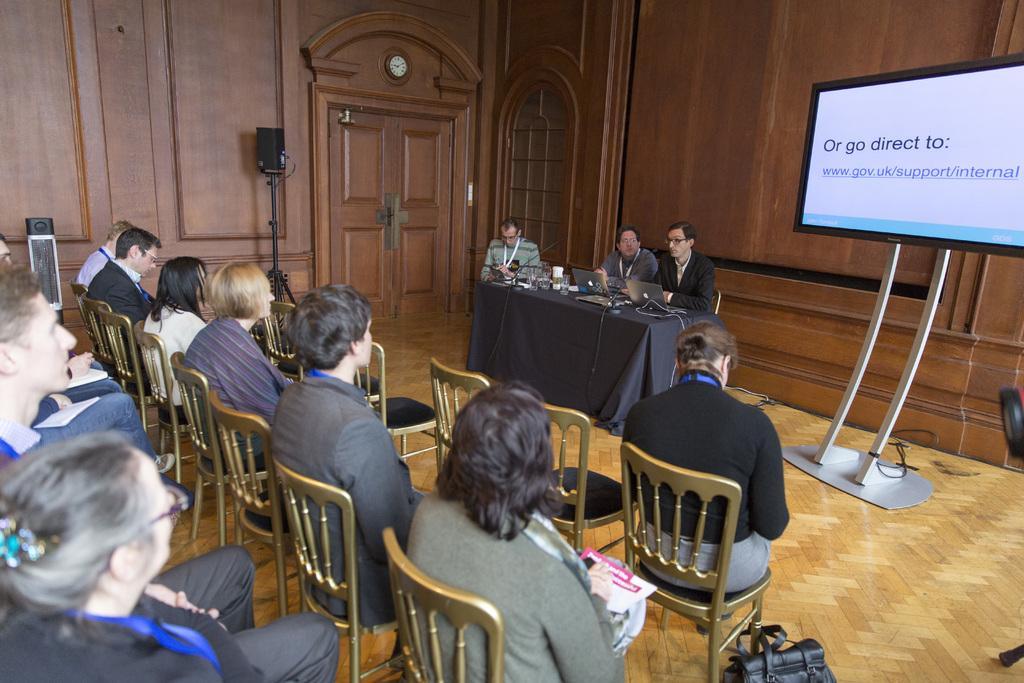Please provide a concise description of this image. There are three people sitting behind the table. There is a table which covered with black color cloth and there are glass and laptops on the table and at the left people sitting on the chair. There is a television at the right and at the back there is a door and there is clock above the door, there is a speaker beside of the door. 